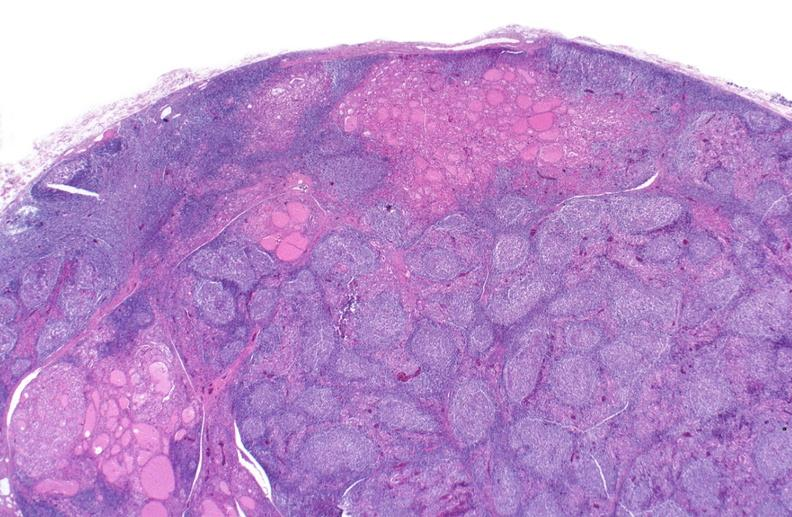s lymphangiomatosis present?
Answer the question using a single word or phrase. No 